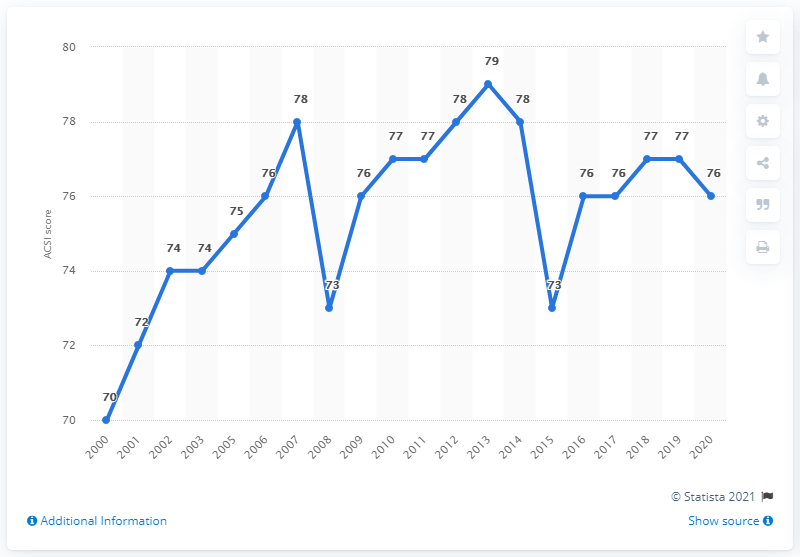Mention a couple of crucial points in this snapshot. In 2020, Wendy's ACSI score was 76, indicating a high level of customer satisfaction. 